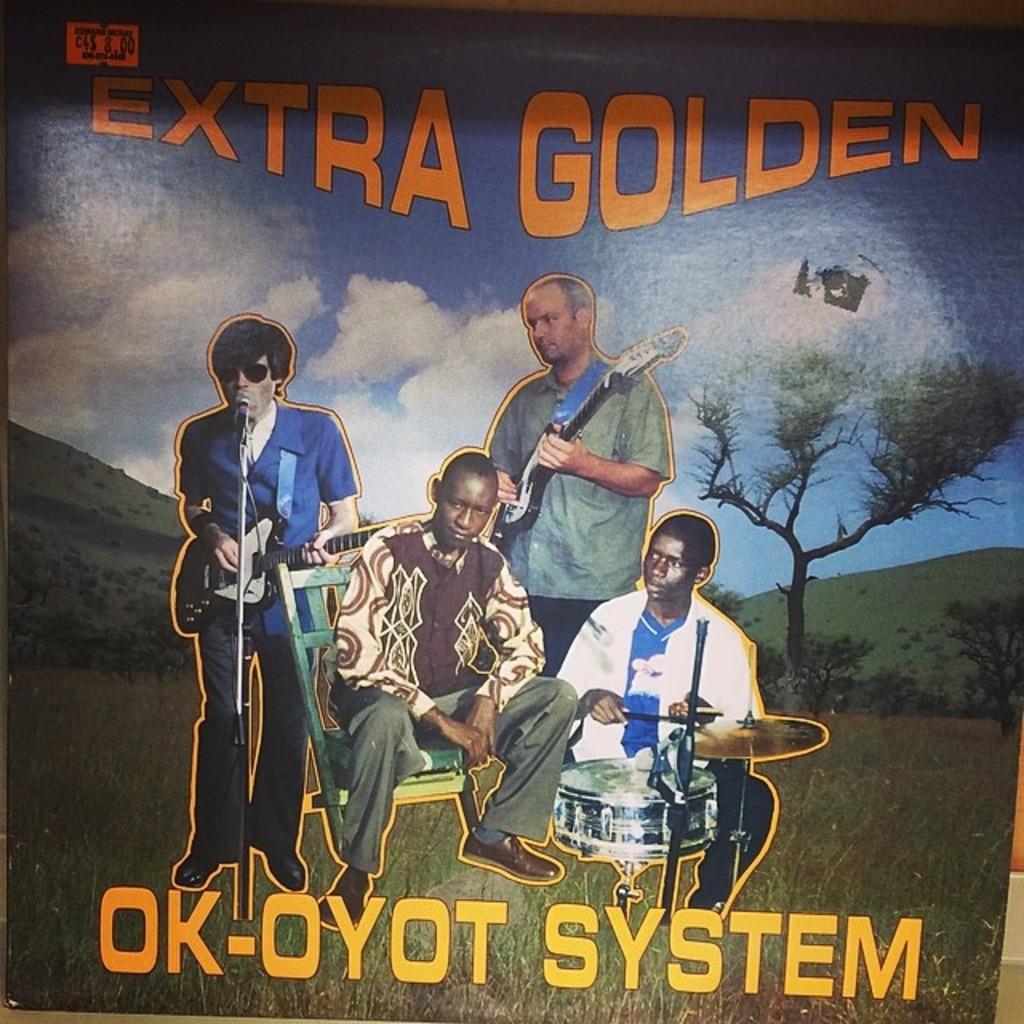Is this a movie or band?
Offer a terse response. Band. What is the album title?
Your answer should be very brief. Extra golden. 